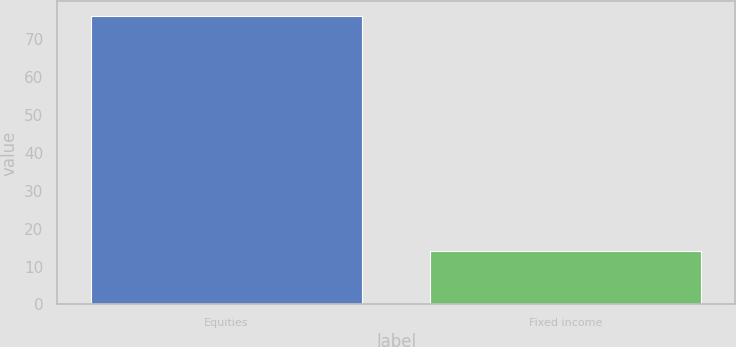<chart> <loc_0><loc_0><loc_500><loc_500><bar_chart><fcel>Equities<fcel>Fixed income<nl><fcel>76<fcel>14<nl></chart> 